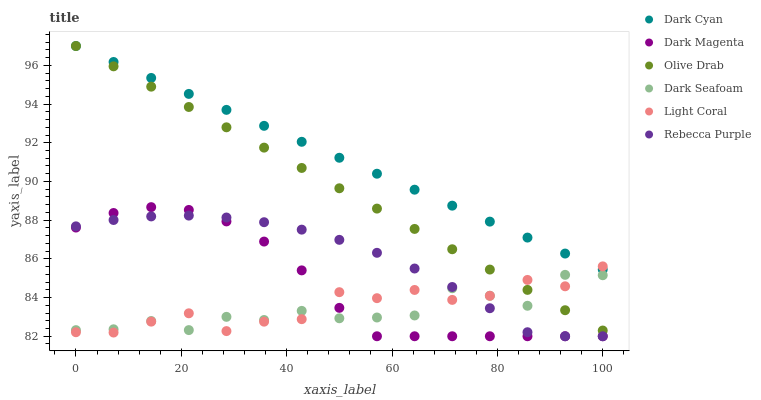Does Dark Seafoam have the minimum area under the curve?
Answer yes or no. Yes. Does Dark Cyan have the maximum area under the curve?
Answer yes or no. Yes. Does Light Coral have the minimum area under the curve?
Answer yes or no. No. Does Light Coral have the maximum area under the curve?
Answer yes or no. No. Is Dark Cyan the smoothest?
Answer yes or no. Yes. Is Light Coral the roughest?
Answer yes or no. Yes. Is Dark Seafoam the smoothest?
Answer yes or no. No. Is Dark Seafoam the roughest?
Answer yes or no. No. Does Dark Magenta have the lowest value?
Answer yes or no. Yes. Does Light Coral have the lowest value?
Answer yes or no. No. Does Olive Drab have the highest value?
Answer yes or no. Yes. Does Light Coral have the highest value?
Answer yes or no. No. Is Dark Seafoam less than Dark Cyan?
Answer yes or no. Yes. Is Dark Cyan greater than Rebecca Purple?
Answer yes or no. Yes. Does Dark Cyan intersect Light Coral?
Answer yes or no. Yes. Is Dark Cyan less than Light Coral?
Answer yes or no. No. Is Dark Cyan greater than Light Coral?
Answer yes or no. No. Does Dark Seafoam intersect Dark Cyan?
Answer yes or no. No. 